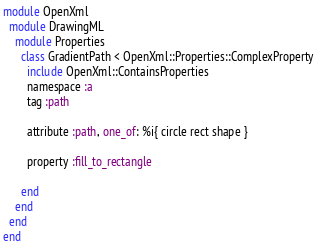Convert code to text. <code><loc_0><loc_0><loc_500><loc_500><_Ruby_>module OpenXml
  module DrawingML
    module Properties
      class GradientPath < OpenXml::Properties::ComplexProperty
        include OpenXml::ContainsProperties
        namespace :a
        tag :path

        attribute :path, one_of: %i{ circle rect shape }

        property :fill_to_rectangle

      end
    end
  end
end
</code> 